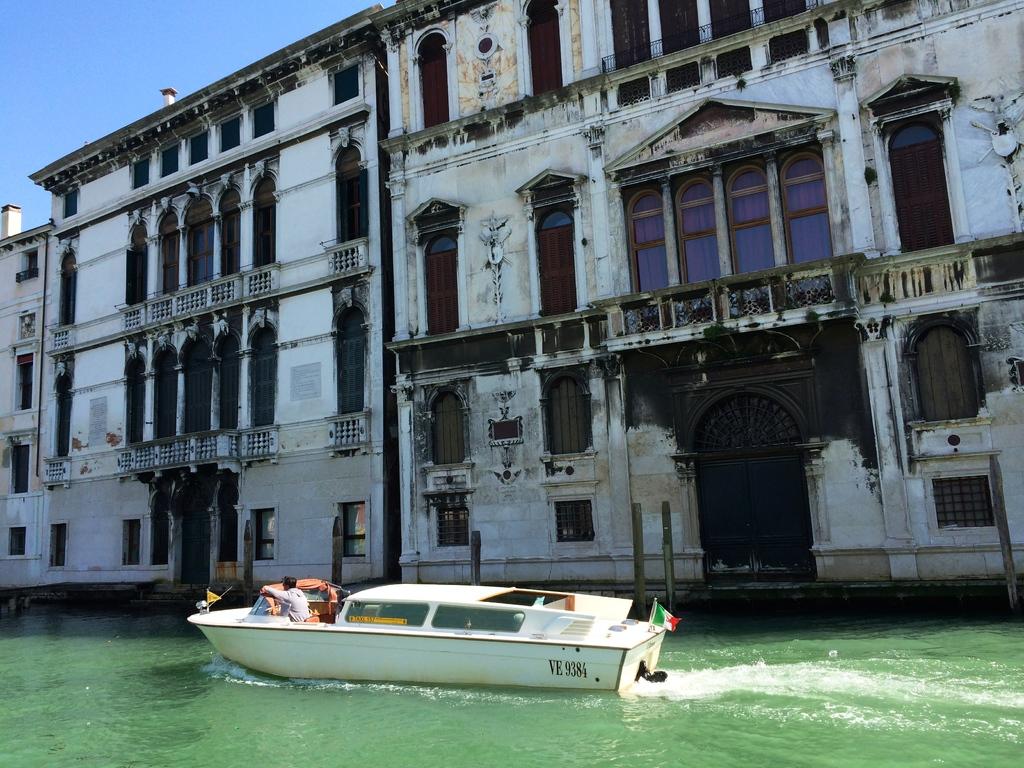What are the letters and numbers on the boat?
Ensure brevity in your answer.  Ve 9384. What color is the numbers on the boat?
Keep it short and to the point. Answering does not require reading text in the image. 